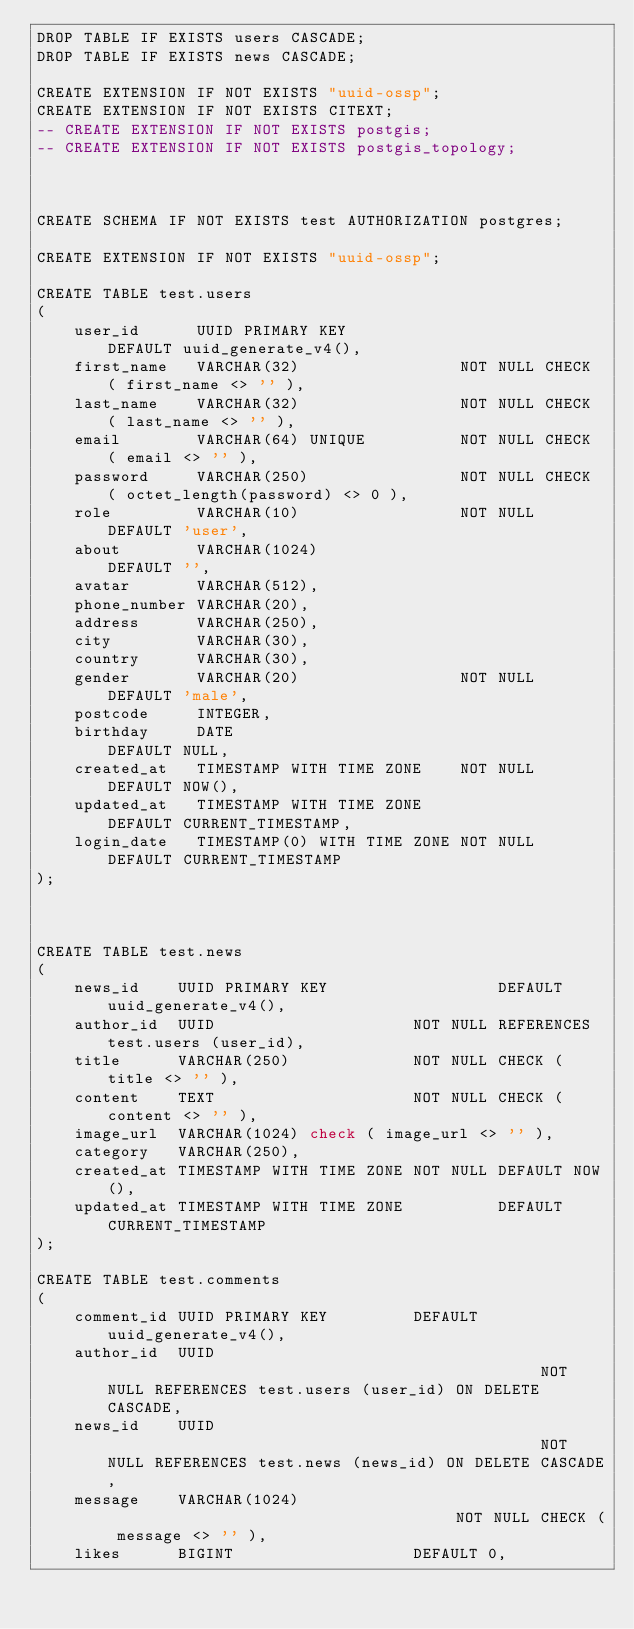<code> <loc_0><loc_0><loc_500><loc_500><_SQL_>DROP TABLE IF EXISTS users CASCADE;
DROP TABLE IF EXISTS news CASCADE;

CREATE EXTENSION IF NOT EXISTS "uuid-ossp";
CREATE EXTENSION IF NOT EXISTS CITEXT;
-- CREATE EXTENSION IF NOT EXISTS postgis;
-- CREATE EXTENSION IF NOT EXISTS postgis_topology;



CREATE SCHEMA IF NOT EXISTS test AUTHORIZATION postgres;

CREATE EXTENSION IF NOT EXISTS "uuid-ossp";

CREATE TABLE test.users
(
    user_id      UUID PRIMARY KEY                     DEFAULT uuid_generate_v4(),
    first_name   VARCHAR(32)                 NOT NULL CHECK ( first_name <> '' ),
    last_name    VARCHAR(32)                 NOT NULL CHECK ( last_name <> '' ),
    email        VARCHAR(64) UNIQUE          NOT NULL CHECK ( email <> '' ),
    password     VARCHAR(250)                NOT NULL CHECK ( octet_length(password) <> 0 ),
    role         VARCHAR(10)                 NOT NULL DEFAULT 'user',
    about        VARCHAR(1024)                        DEFAULT '',
    avatar       VARCHAR(512),
    phone_number VARCHAR(20),
    address      VARCHAR(250),
    city         VARCHAR(30),
    country      VARCHAR(30),
    gender       VARCHAR(20)                 NOT NULL DEFAULT 'male',
    postcode     INTEGER,
    birthday     DATE                                 DEFAULT NULL,
    created_at   TIMESTAMP WITH TIME ZONE    NOT NULL DEFAULT NOW(),
    updated_at   TIMESTAMP WITH TIME ZONE             DEFAULT CURRENT_TIMESTAMP,
    login_date   TIMESTAMP(0) WITH TIME ZONE NOT NULL DEFAULT CURRENT_TIMESTAMP
);



CREATE TABLE test.news
(
    news_id    UUID PRIMARY KEY                  DEFAULT uuid_generate_v4(),
    author_id  UUID                     NOT NULL REFERENCES test.users (user_id),
    title      VARCHAR(250)             NOT NULL CHECK ( title <> '' ),
    content    TEXT                     NOT NULL CHECK ( content <> '' ),
    image_url  VARCHAR(1024) check ( image_url <> '' ),
    category   VARCHAR(250),
    created_at TIMESTAMP WITH TIME ZONE NOT NULL DEFAULT NOW(),
    updated_at TIMESTAMP WITH TIME ZONE          DEFAULT CURRENT_TIMESTAMP
);

CREATE TABLE test.comments
(
    comment_id UUID PRIMARY KEY         DEFAULT uuid_generate_v4(),
    author_id  UUID                                               NOT NULL REFERENCES test.users (user_id) ON DELETE CASCADE,
    news_id    UUID                                               NOT NULL REFERENCES test.news (news_id) ON DELETE CASCADE,
    message    VARCHAR(1024)                                      NOT NULL CHECK ( message <> '' ),
    likes      BIGINT                   DEFAULT 0,</code> 